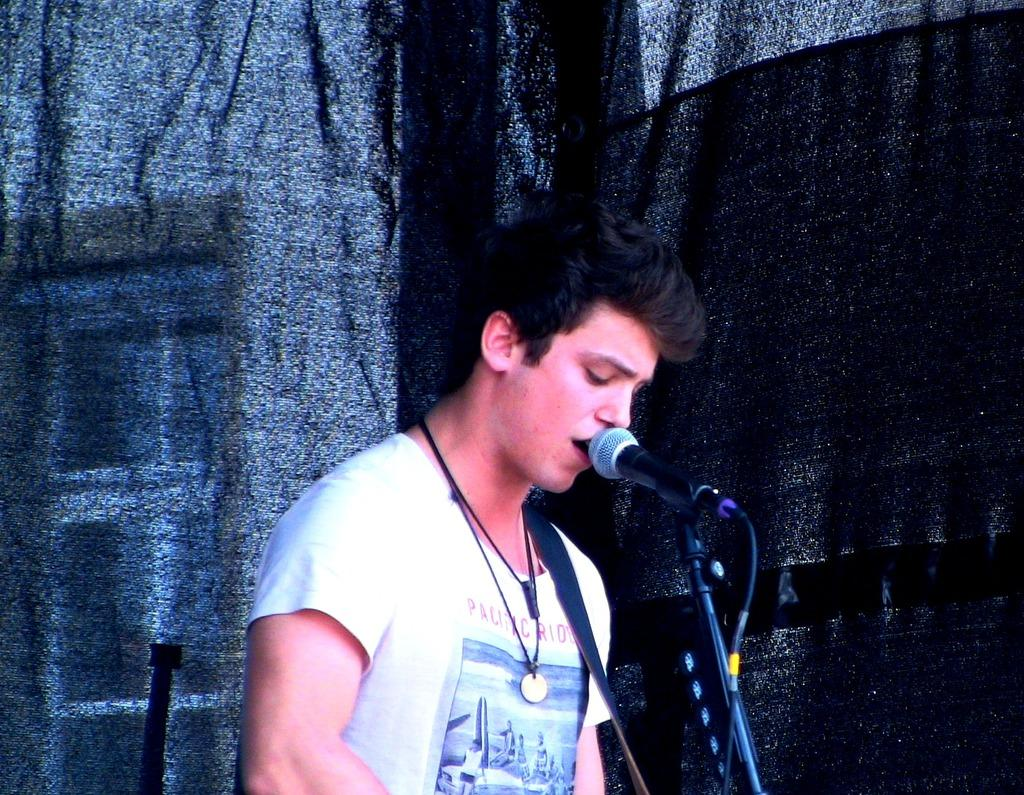Who or what is the main subject in the image? There is a person in the image. What can be observed about the background of the image? The background of the image is dark. What is the person wearing in the image? The person is wearing clothes. What object is located at the bottom of the image? There is a mic at the bottom of the image. What type of berry is being used as a prop in the image? There is no berry present in the image. How many stars can be seen in the image? There are no stars visible in the image. 